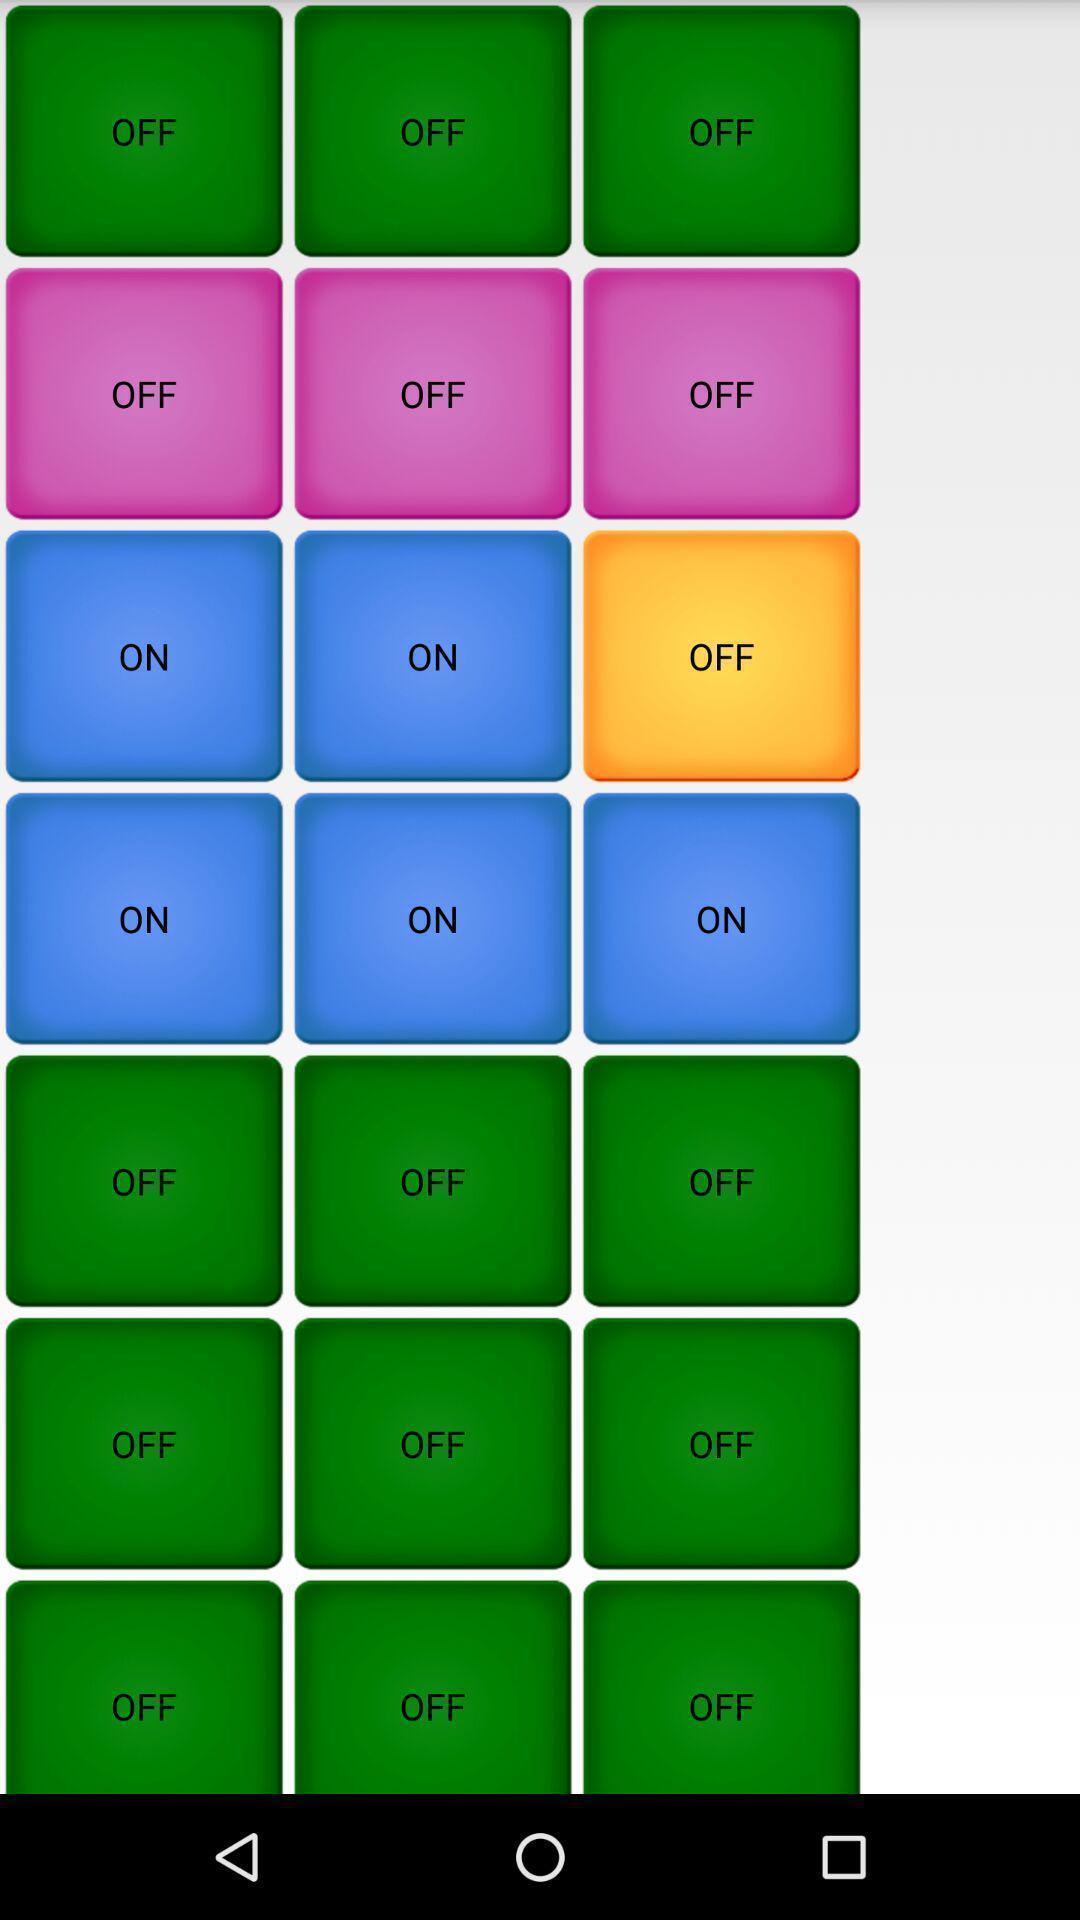Provide a description of this screenshot. Screen shows random buttons on a screen. 